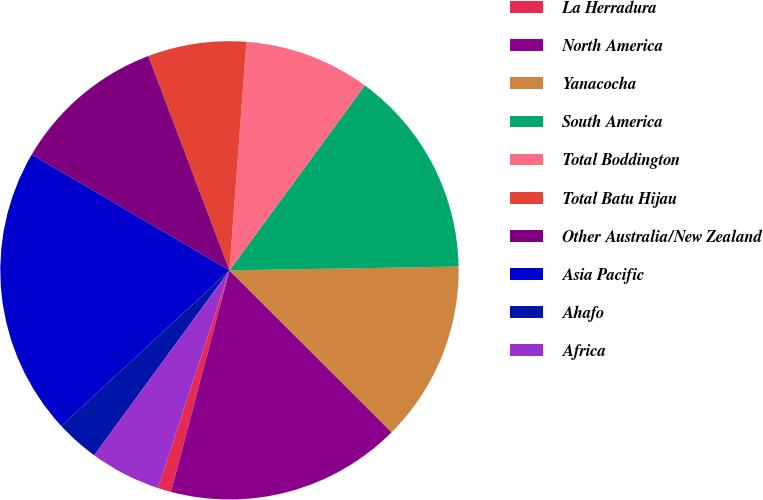<chart> <loc_0><loc_0><loc_500><loc_500><pie_chart><fcel>La Herradura<fcel>North America<fcel>Yanacocha<fcel>South America<fcel>Total Boddington<fcel>Total Batu Hijau<fcel>Other Australia/New Zealand<fcel>Asia Pacific<fcel>Ahafo<fcel>Africa<nl><fcel>0.94%<fcel>16.62%<fcel>12.75%<fcel>14.68%<fcel>8.88%<fcel>6.94%<fcel>10.81%<fcel>20.31%<fcel>3.07%<fcel>5.0%<nl></chart> 